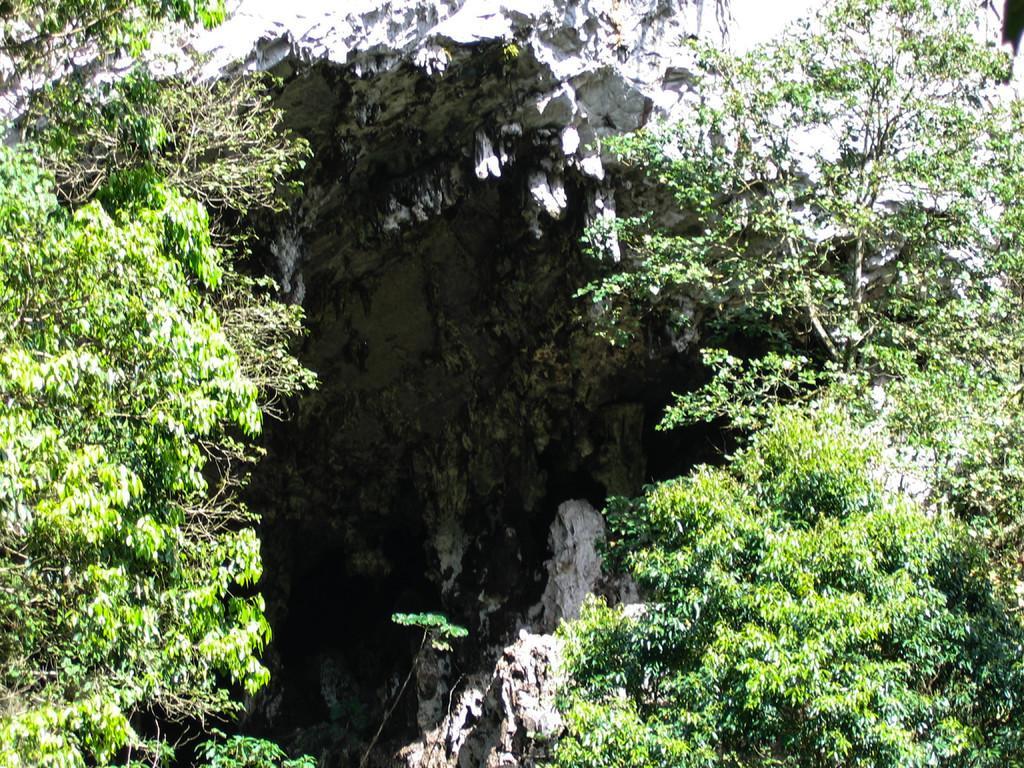In one or two sentences, can you explain what this image depicts? In this picture I can see trees and a rock. 